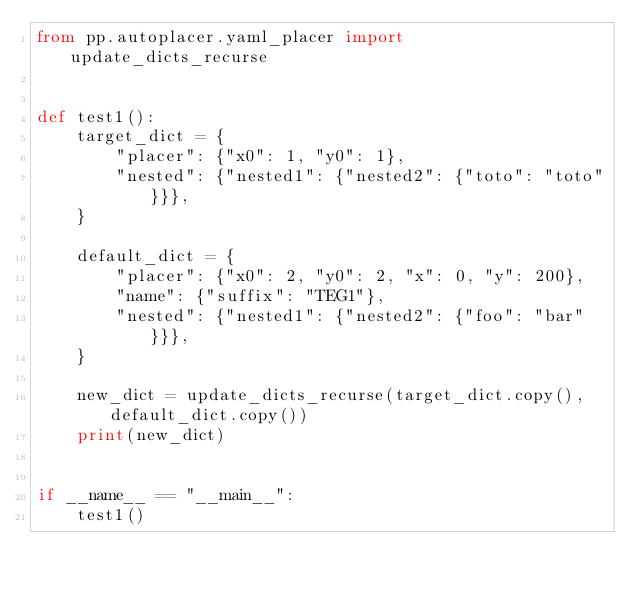Convert code to text. <code><loc_0><loc_0><loc_500><loc_500><_Python_>from pp.autoplacer.yaml_placer import update_dicts_recurse


def test1():
    target_dict = {
        "placer": {"x0": 1, "y0": 1},
        "nested": {"nested1": {"nested2": {"toto": "toto"}}},
    }

    default_dict = {
        "placer": {"x0": 2, "y0": 2, "x": 0, "y": 200},
        "name": {"suffix": "TEG1"},
        "nested": {"nested1": {"nested2": {"foo": "bar"}}},
    }

    new_dict = update_dicts_recurse(target_dict.copy(), default_dict.copy())
    print(new_dict)


if __name__ == "__main__":
    test1()
</code> 